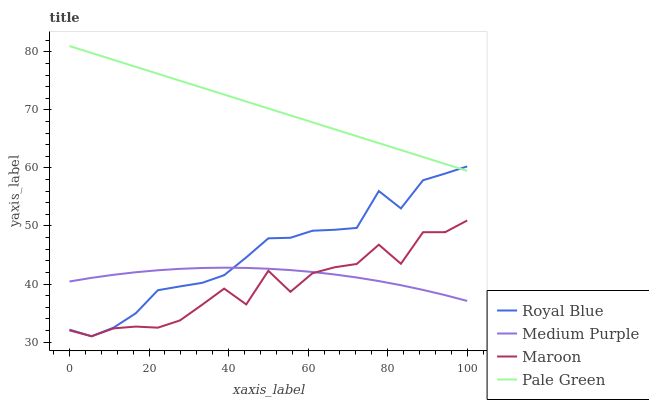Does Maroon have the minimum area under the curve?
Answer yes or no. Yes. Does Pale Green have the maximum area under the curve?
Answer yes or no. Yes. Does Royal Blue have the minimum area under the curve?
Answer yes or no. No. Does Royal Blue have the maximum area under the curve?
Answer yes or no. No. Is Pale Green the smoothest?
Answer yes or no. Yes. Is Maroon the roughest?
Answer yes or no. Yes. Is Royal Blue the smoothest?
Answer yes or no. No. Is Royal Blue the roughest?
Answer yes or no. No. Does Royal Blue have the lowest value?
Answer yes or no. Yes. Does Pale Green have the lowest value?
Answer yes or no. No. Does Pale Green have the highest value?
Answer yes or no. Yes. Does Royal Blue have the highest value?
Answer yes or no. No. Is Medium Purple less than Pale Green?
Answer yes or no. Yes. Is Pale Green greater than Maroon?
Answer yes or no. Yes. Does Maroon intersect Medium Purple?
Answer yes or no. Yes. Is Maroon less than Medium Purple?
Answer yes or no. No. Is Maroon greater than Medium Purple?
Answer yes or no. No. Does Medium Purple intersect Pale Green?
Answer yes or no. No. 